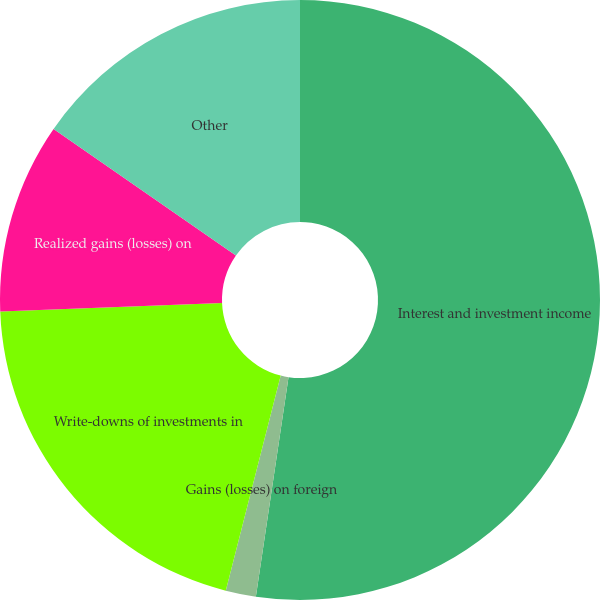Convert chart. <chart><loc_0><loc_0><loc_500><loc_500><pie_chart><fcel>Interest and investment income<fcel>Gains (losses) on foreign<fcel>Write-downs of investments in<fcel>Realized gains (losses) on<fcel>Other<nl><fcel>52.35%<fcel>1.63%<fcel>20.41%<fcel>10.27%<fcel>15.34%<nl></chart> 